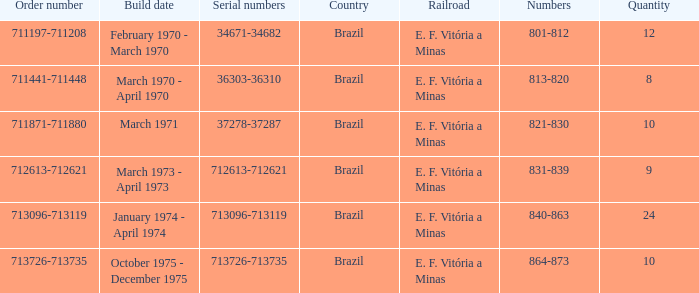What are the values for the order number 713096-713119? 840-863. 